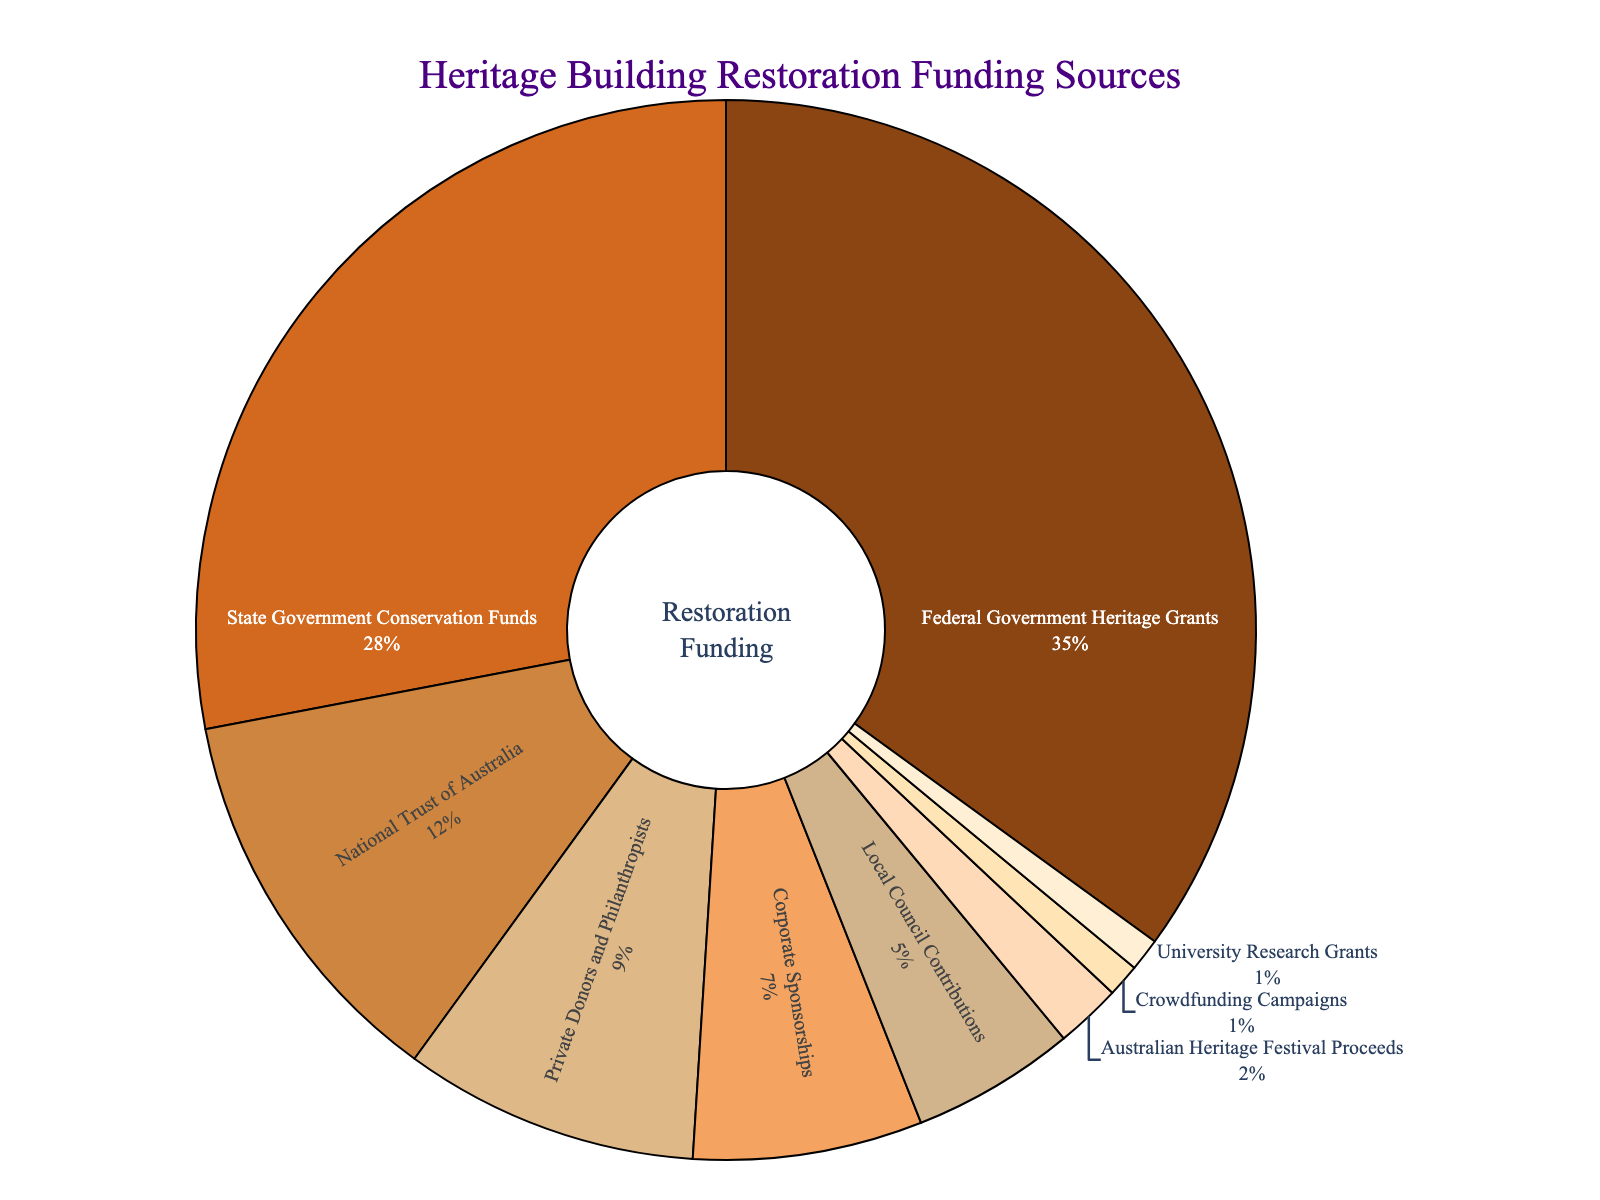Which two funding sources combined make up more than half of the total funding? We need to find two sources whose combined percentage exceeds 50%. The Federal Government Heritage Grants (35%) and State Government Conservation Funds (28%) sum up to 63%, which is more than half.
Answer: Federal Government Heritage Grants and State Government Conservation Funds How much larger is the percentage of funds from the Federal Government Heritage Grants compared to Corporate Sponsorships? Subtract the percentage of Corporate Sponsorships (7%) from the Federal Government Heritage Grants (35%). The difference is 35% - 7% = 28%.
Answer: 28% Which funding source contributes the least to the restoration projects? The funding source with the smallest slice on the pie chart corresponds to Crowdfunding Campaigns and University Research Grants, both contributing only 1%.
Answer: Crowdfunding Campaigns and University Research Grants What percentage of the total funding is contributed by non-governmental sources? Add up the percentages of all non-governmental sources: National Trust of Australia (12%), Private Donors and Philanthropists (9%), Corporate Sponsorships (7%), Australian Heritage Festival Proceeds (2%), Crowdfunding Campaigns (1%), and University Research Grants (1%). The total is 12% + 9% + 7% + 2% + 1% + 1% = 32%.
Answer: 32% Which two funding sources have the closest funding percentages, and what is the difference between them? Compare the percentages of each pair of sources to find the closest ones. The Local Council Contributions (5%) and Corporate Sponsorships (7%) have a difference of 7% - 5% = 2%.
Answer: Local Council Contributions and Corporate Sponsorships; 2% What is the approximate ratio of federal to state government funding? Divide the percentage of Federal Government Heritage Grants (35%) by the percentage of State Government Conservation Funds (28%). Simplify the ratio 35:28 to its simplest form, which is 5:4.
Answer: 5:4 If funding from Private Donors and Philanthropists increased by 5%, how much would their new percentage of total funding be? Add 5% to the current percentage from Private Donors and Philanthropists (9%). The new percentage would be 9% + 5% = 14%.
Answer: 14% What portion of the pie chart is represented by Local Council Contributions? The Local Council Contributions segment is visually about one-twentieth of the pie chart since it represents 5% of the total funding.
Answer: 5% What is the combined contribution of both university and festival funding sources? Add the percentages of University Research Grants (1%) and Australian Heritage Festival Proceeds (2%). The total combined contribution is 1% + 2% = 3%.
Answer: 3% 